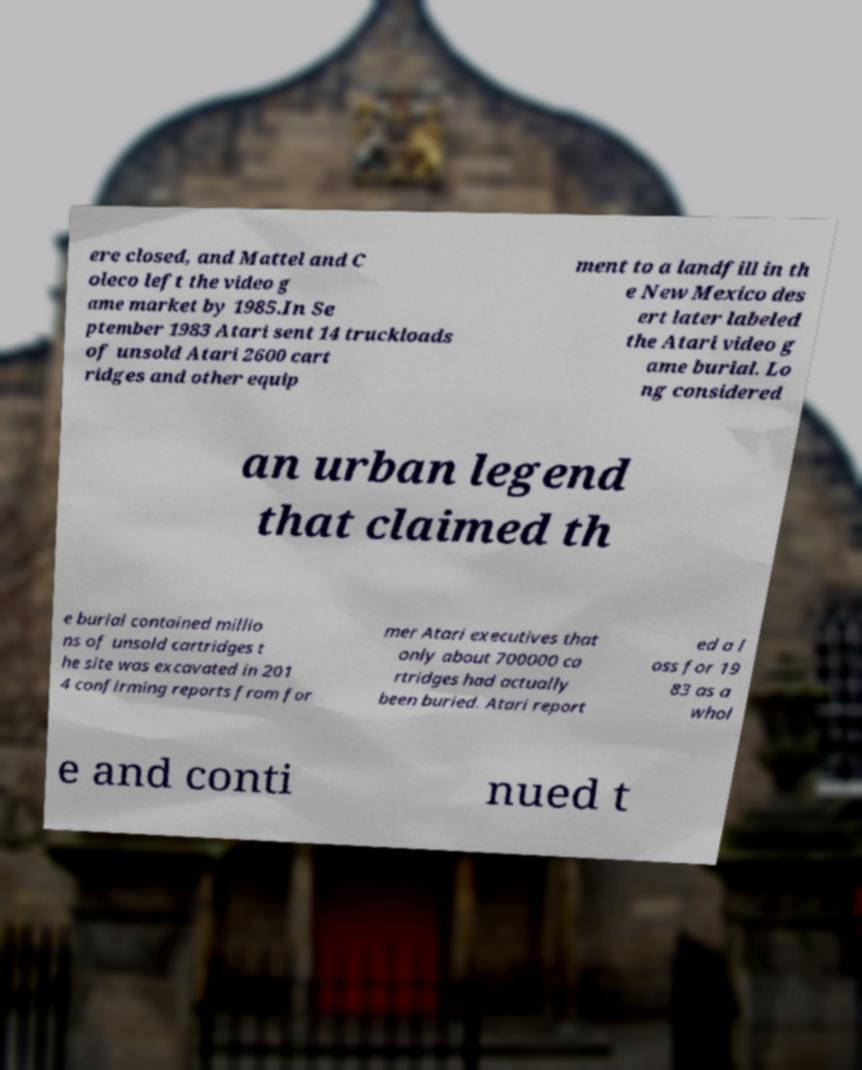I need the written content from this picture converted into text. Can you do that? ere closed, and Mattel and C oleco left the video g ame market by 1985.In Se ptember 1983 Atari sent 14 truckloads of unsold Atari 2600 cart ridges and other equip ment to a landfill in th e New Mexico des ert later labeled the Atari video g ame burial. Lo ng considered an urban legend that claimed th e burial contained millio ns of unsold cartridges t he site was excavated in 201 4 confirming reports from for mer Atari executives that only about 700000 ca rtridges had actually been buried. Atari report ed a l oss for 19 83 as a whol e and conti nued t 